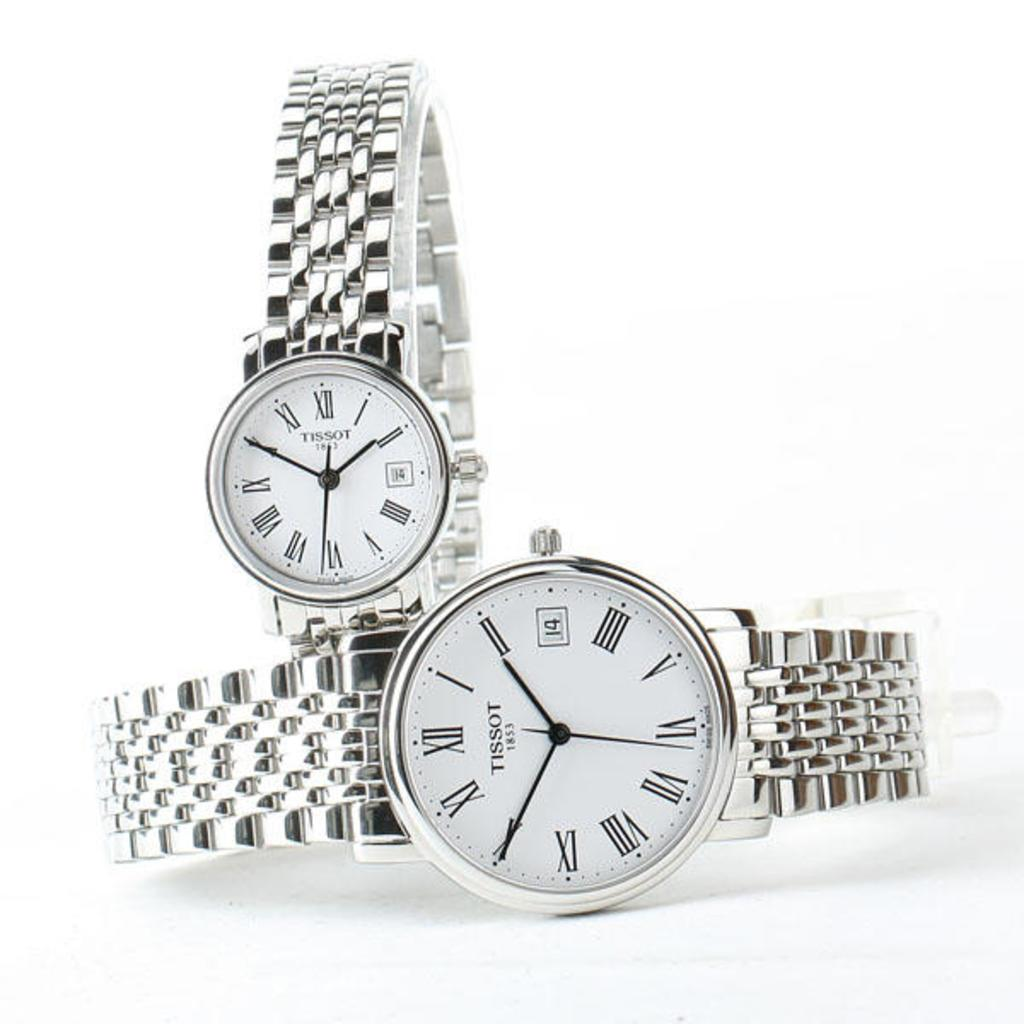<image>
Provide a brief description of the given image. Silver watch next to another one both saying the word TISSOT on it. 